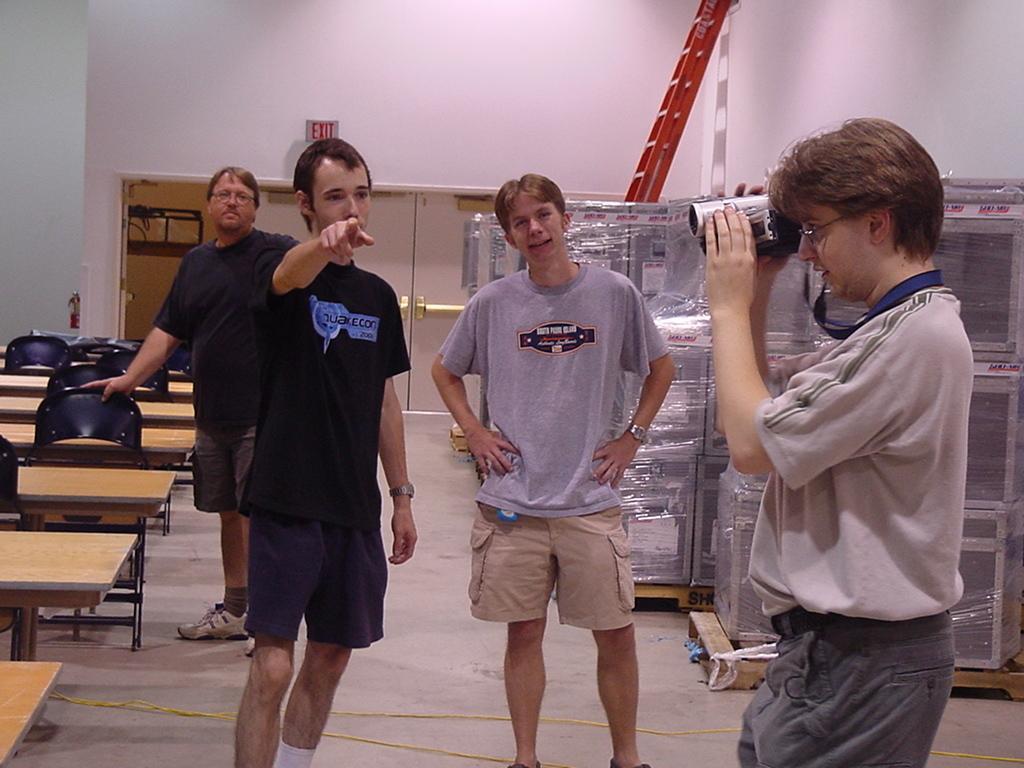Describe this image in one or two sentences. In the middle of the image few people are standing and he is holding a camera. Behind them there are benches and chairs. At the top of the image there is wall and ladder and sign board. 